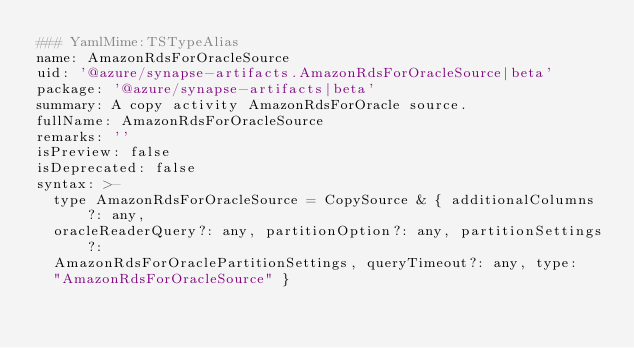Convert code to text. <code><loc_0><loc_0><loc_500><loc_500><_YAML_>### YamlMime:TSTypeAlias
name: AmazonRdsForOracleSource
uid: '@azure/synapse-artifacts.AmazonRdsForOracleSource|beta'
package: '@azure/synapse-artifacts|beta'
summary: A copy activity AmazonRdsForOracle source.
fullName: AmazonRdsForOracleSource
remarks: ''
isPreview: false
isDeprecated: false
syntax: >-
  type AmazonRdsForOracleSource = CopySource & { additionalColumns?: any,
  oracleReaderQuery?: any, partitionOption?: any, partitionSettings?:
  AmazonRdsForOraclePartitionSettings, queryTimeout?: any, type:
  "AmazonRdsForOracleSource" }
</code> 